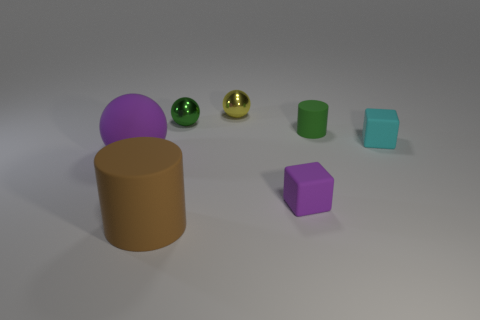The thing that is the same color as the rubber ball is what shape?
Your answer should be compact. Cube. Are there any cyan matte objects of the same shape as the tiny yellow object?
Keep it short and to the point. No. The green metallic thing that is the same size as the cyan thing is what shape?
Offer a terse response. Sphere. There is a big ball; does it have the same color as the matte block that is on the right side of the tiny purple matte block?
Your answer should be compact. No. There is a cylinder behind the cyan block; what number of small purple blocks are behind it?
Your response must be concise. 0. What is the size of the thing that is both in front of the big purple sphere and right of the big brown matte thing?
Your answer should be compact. Small. Are there any brown cylinders of the same size as the cyan thing?
Provide a short and direct response. No. Is the number of large brown objects that are to the right of the tiny yellow shiny thing greater than the number of small green objects in front of the big brown matte object?
Your answer should be very brief. No. Is the material of the tiny green ball the same as the brown cylinder to the right of the big purple sphere?
Provide a short and direct response. No. What number of cylinders are in front of the rubber cylinder right of the tiny green object that is to the left of the small yellow shiny thing?
Provide a succinct answer. 1. 